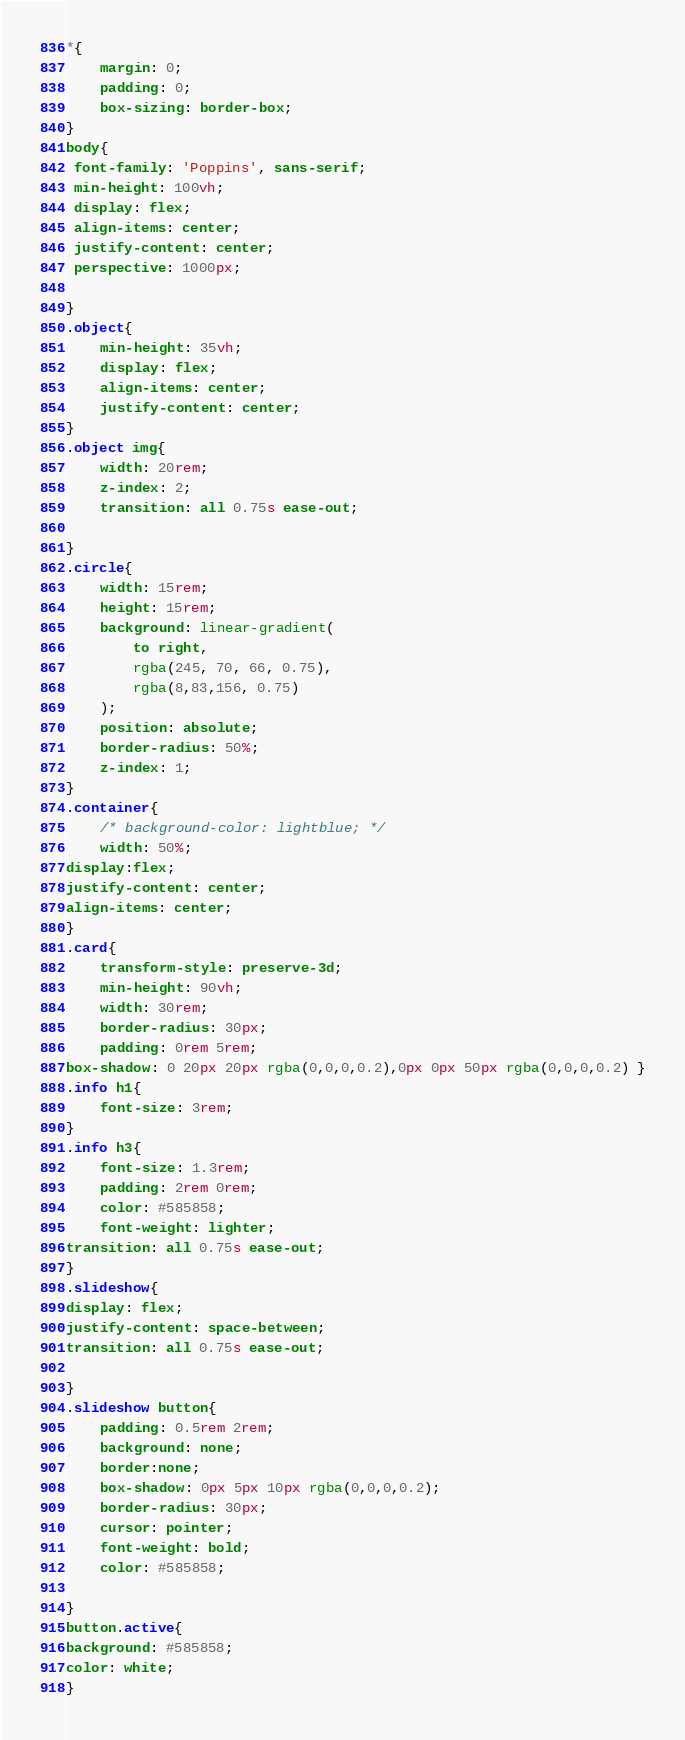Convert code to text. <code><loc_0><loc_0><loc_500><loc_500><_CSS_>*{
    margin: 0;
    padding: 0;
    box-sizing: border-box;
}
body{
 font-family: 'Poppins', sans-serif;
 min-height: 100vh;
 display: flex;
 align-items: center;
 justify-content: center;
 perspective: 1000px;

}
.object{
    min-height: 35vh;
    display: flex;
    align-items: center;
    justify-content: center;
}
.object img{
    width: 20rem;
    z-index: 2;
    transition: all 0.75s ease-out;

}
.circle{
    width: 15rem;
    height: 15rem;
    background: linear-gradient(
        to right,
        rgba(245, 70, 66, 0.75),
        rgba(8,83,156, 0.75)
    );
    position: absolute;
    border-radius: 50%;
    z-index: 1;
}
.container{
    /* background-color: lightblue; */
    width: 50%;
display:flex;
justify-content: center;
align-items: center;
}
.card{
    transform-style: preserve-3d;
    min-height: 90vh;
    width: 30rem;
    border-radius: 30px;
    padding: 0rem 5rem;
box-shadow: 0 20px 20px rgba(0,0,0,0.2),0px 0px 50px rgba(0,0,0,0.2) }
.info h1{
    font-size: 3rem;
}
.info h3{
    font-size: 1.3rem;
    padding: 2rem 0rem;
    color: #585858;
    font-weight: lighter;
transition: all 0.75s ease-out;
}
.slideshow{
display: flex;
justify-content: space-between;
transition: all 0.75s ease-out;

}
.slideshow button{
    padding: 0.5rem 2rem;
    background: none;
    border:none;
    box-shadow: 0px 5px 10px rgba(0,0,0,0.2);
    border-radius: 30px;
    cursor: pointer;
    font-weight: bold;
    color: #585858;

}
button.active{
background: #585858;
color: white; 
}</code> 